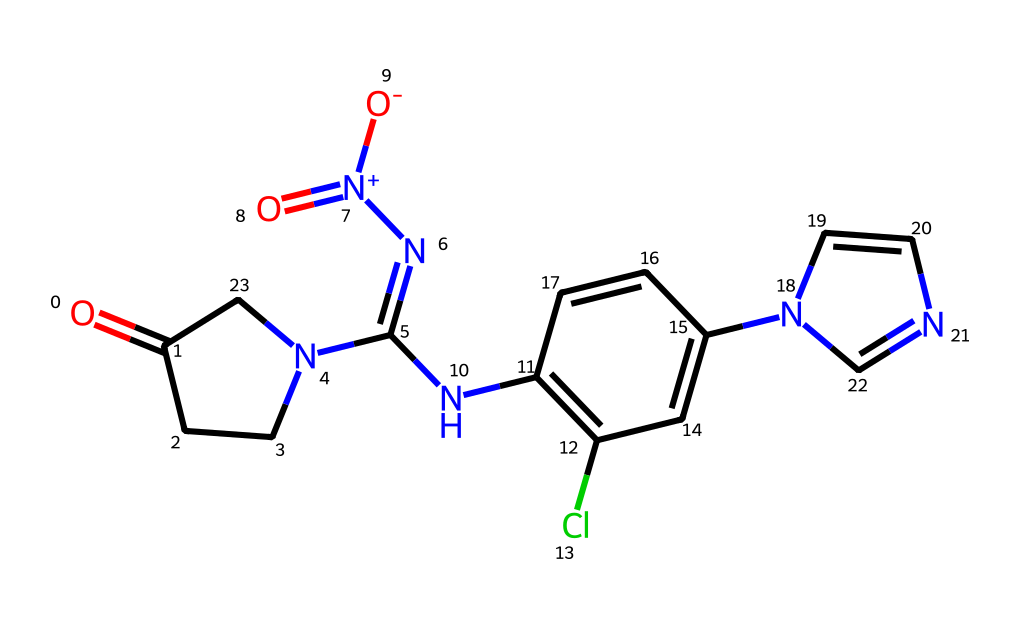What is the core functional group present in this structure? The structure contains a pyridine ring, which is characterized by a six-membered aromatic ring containing one nitrogen atom. This functional group is critical in defining the reactivity and properties of neonicotinoids.
Answer: pyridine How many nitrogen atoms are in this compound? By analyzing the structure, there are a total of four nitrogen atoms present. Two are part of the amine groups, one is part of the nitro group, and one is in the pyridine ring.
Answer: four What type of chemical bonding is predominant in this molecule? The molecule predominantly features covalent bonding as it consists of various atoms sharing electrons to form stable connections, characteristic of organic molecules.
Answer: covalent What is the overall charge of this molecule? Upon inspecting the chemical structure, it is noted that there is a positive charge on one of the nitrogen atoms and a negative charge on one of the oxygen atoms, resulting in a net charge of +1 overall.
Answer: +1 Is there a chlorine substituent present in the structure? Yes, the structure contains a chlorine atom attached to the aromatic ring indicated by "Cl", which is a common substitution in neonicotinoids that enhances their insecticidal properties.
Answer: yes What is the primary mechanism by which this class of pesticides affects insects? Neonicotinoids primarily act by selectively binding to nicotinic acetylcholine receptors in the nervous system of insects, leading to paralysis and death.
Answer: binding How may this chemical structure lead to potential toxicity in birds? The extensive similarities between insect and vertebrate nicotinic receptors may cause this chemical to bind to and disrupt the normal functioning of avian receptors, leading to possible neurotoxic effects in birds.
Answer: neurotoxic effects 